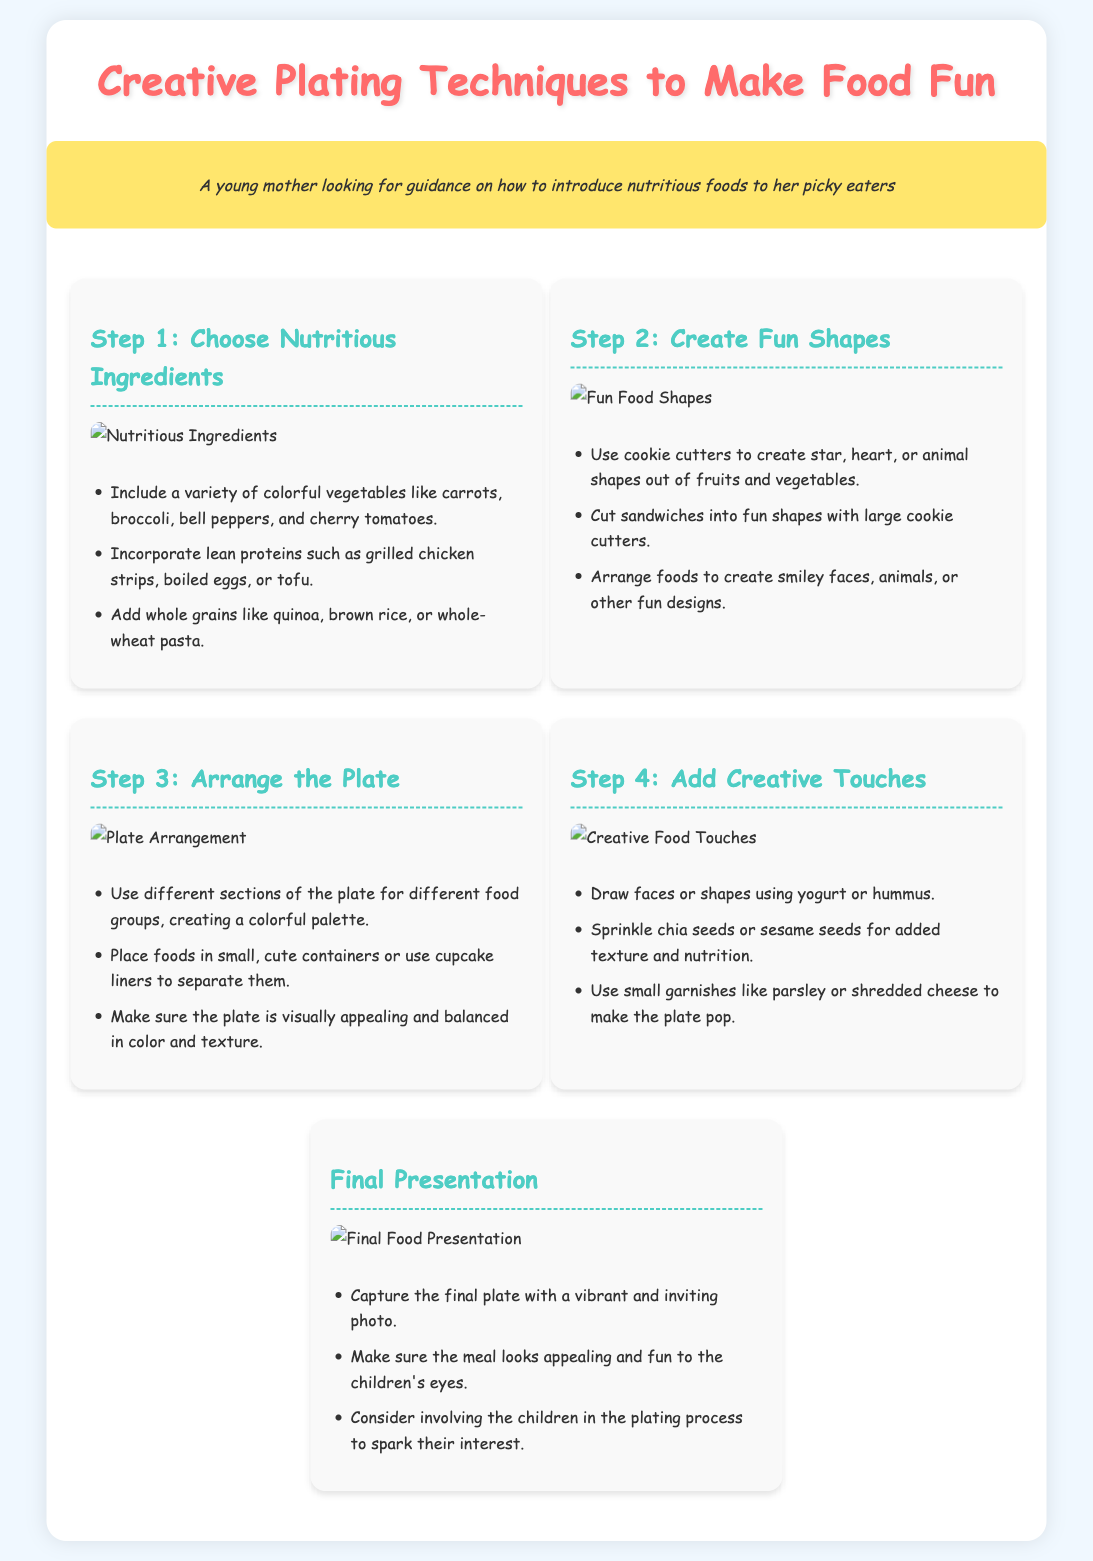What is the title of the infographic? The title is located at the top of the document, clearly stated in a large font.
Answer: Creative Plating Techniques to Make Food Fun What is the first step in the process? The first step is explicitly stated in the document as part of the process sections.
Answer: Choose Nutritious Ingredients How many main steps are shown in the infographic? The number of steps can be counted from the main headings included in the process.
Answer: Five What ingredient is suggested for creating fun shapes? The document mentions specific ingredients suitable for shaping.
Answer: Fruits and vegetables What color are the step titles? The color of the titles is consistently used throughout the steps.
Answer: Aqua What should you use to create face designs on the plate? The document specifies a type of food that can be used for decoration.
Answer: Yogurt or hummus Which step emphasizes the importance of plate presentation? This indicates the significance of the final arrangement in the overall process.
Answer: Final Presentation What is recommended for separating different food groups on the plate? The document suggests specific items for visually separating foods.
Answer: Small containers or cupcake liners Which type of cheese is mentioned for garnishing? This detail highlights the suggested topping for enhancing the meal's appeal.
Answer: Shredded cheese 